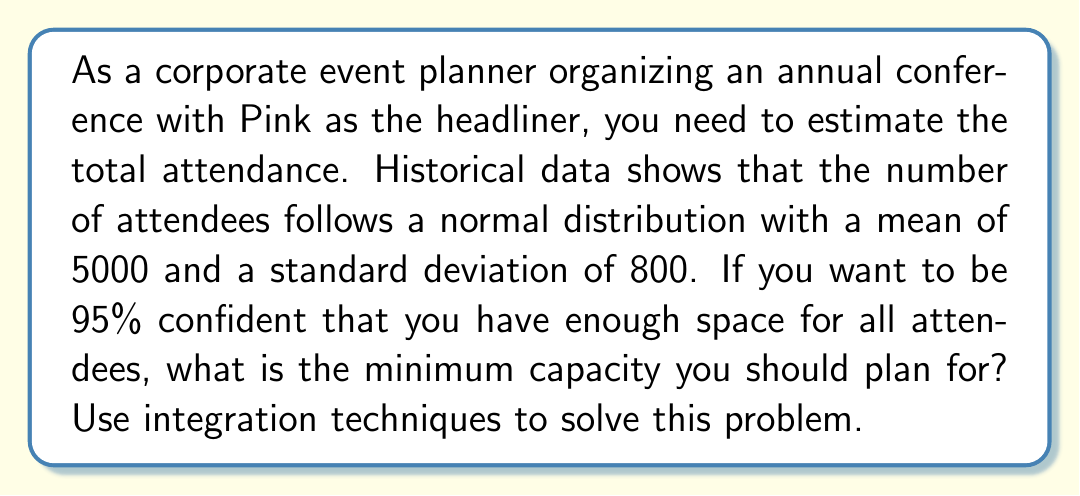Teach me how to tackle this problem. To solve this problem, we need to use the properties of the normal distribution and integration techniques. Let's break it down step-by-step:

1) The normal distribution is given by the probability density function:

   $$f(x) = \frac{1}{\sigma\sqrt{2\pi}} e^{-\frac{(x-\mu)^2}{2\sigma^2}}$$

   where $\mu$ is the mean and $\sigma$ is the standard deviation.

2) We're given that $\mu = 5000$ and $\sigma = 800$.

3) To be 95% confident, we need to find the value $x$ such that the probability of an attendance less than or equal to $x$ is 0.95.

4) This can be expressed as an integral:

   $$\int_{-\infty}^x \frac{1}{800\sqrt{2\pi}} e^{-\frac{(t-5000)^2}{2(800)^2}} dt = 0.95$$

5) This integral is difficult to solve directly. Instead, we can use the standard normal distribution by standardizing our variable:

   $$z = \frac{x - \mu}{\sigma} = \frac{x - 5000}{800}$$

6) The problem now becomes finding $z$ such that:

   $$\int_{-\infty}^z \frac{1}{\sqrt{2\pi}} e^{-\frac{t^2}{2}} dt = 0.95$$

7) From standard normal distribution tables or calculators, we can find that this $z$ value is approximately 1.645.

8) Now we can solve for $x$:

   $$\frac{x - 5000}{800} = 1.645$$
   $$x - 5000 = 1.645 * 800$$
   $$x = 5000 + 1.645 * 800 = 6316$$

Therefore, to be 95% confident of accommodating all attendees, you should plan for a minimum capacity of 6316 people.
Answer: 6316 people 